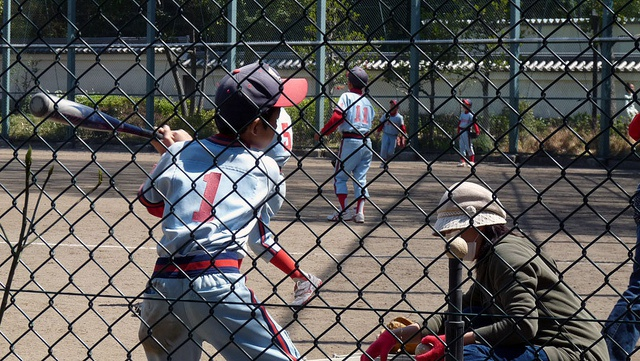Describe the objects in this image and their specific colors. I can see people in darkgreen, black, white, and gray tones, people in darkgreen, black, gray, darkgray, and lightgray tones, people in darkgreen, gray, black, and maroon tones, people in darkgreen, gray, white, black, and darkgray tones, and people in darkgreen, black, navy, maroon, and blue tones in this image. 